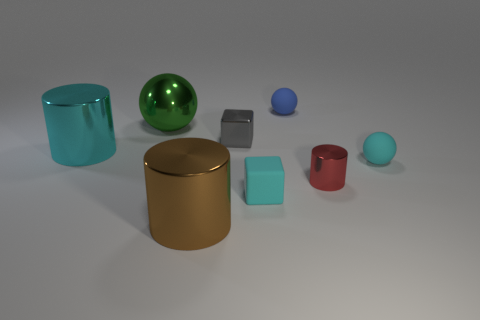What materials do the objects in the image seem to be made of? The objects in the image appear to be made from various materials. The large spheres have a polished, reflective finish suggesting metallic materials, while the cubes and cylinders have different sheens, indicating a possible variety of materials from metals to plastics, all exhibiting properties typical of 3D renderings. 